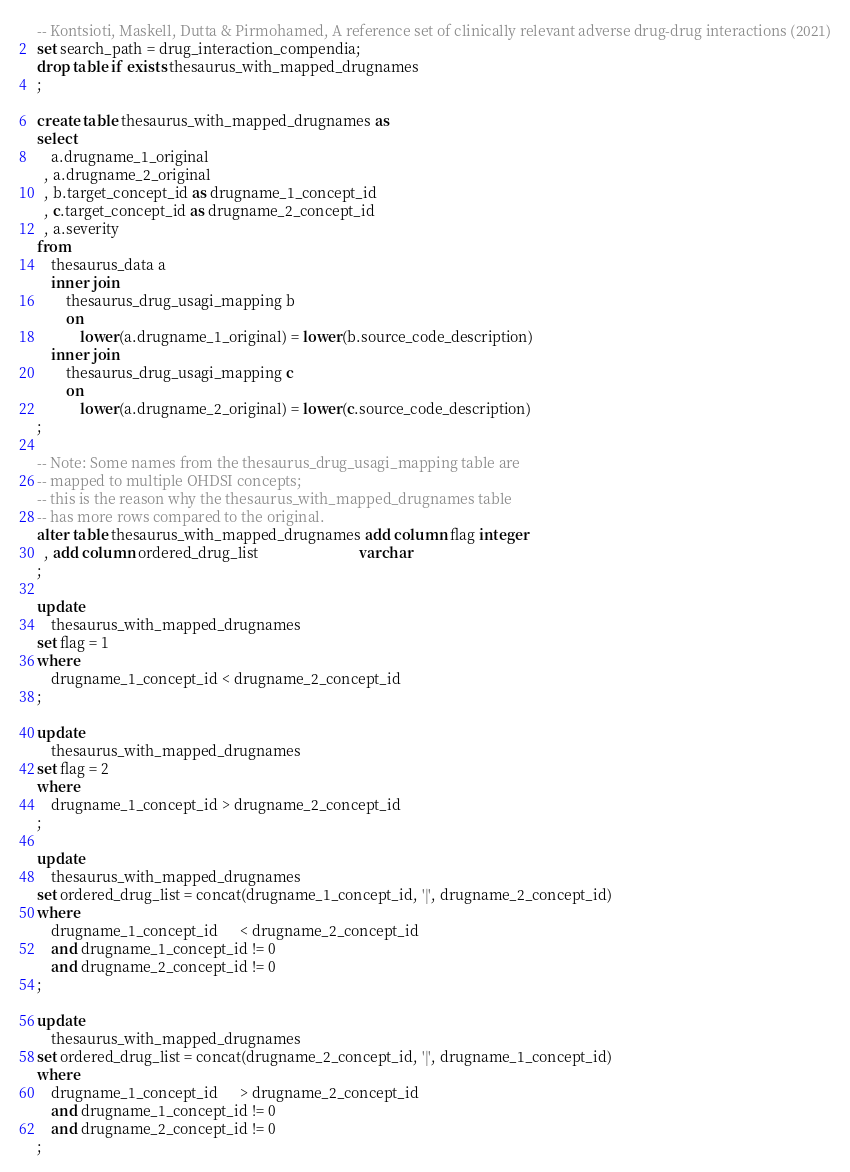Convert code to text. <code><loc_0><loc_0><loc_500><loc_500><_SQL_>-- Kontsioti, Maskell, Dutta & Pirmohamed, A reference set of clinically relevant adverse drug-drug interactions (2021)
set search_path = drug_interaction_compendia;
drop table if exists thesaurus_with_mapped_drugnames
;

create table thesaurus_with_mapped_drugnames as
select
    a.drugname_1_original
  , a.drugname_2_original
  , b.target_concept_id as drugname_1_concept_id
  , c.target_concept_id as drugname_2_concept_id
  , a.severity
from
    thesaurus_data a
    inner join
        thesaurus_drug_usagi_mapping b
        on
            lower(a.drugname_1_original) = lower(b.source_code_description)
    inner join
        thesaurus_drug_usagi_mapping c
        on
            lower(a.drugname_2_original) = lower(c.source_code_description)
;

-- Note: Some names from the thesaurus_drug_usagi_mapping table are 
-- mapped to multiple OHDSI concepts;
-- this is the reason why the thesaurus_with_mapped_drugnames table 
-- has more rows compared to the original.
alter table thesaurus_with_mapped_drugnames add column flag integer
  , add column ordered_drug_list                            varchar
;

update
    thesaurus_with_mapped_drugnames
set flag = 1
where
    drugname_1_concept_id < drugname_2_concept_id
;

update
    thesaurus_with_mapped_drugnames
set flag = 2
where
    drugname_1_concept_id > drugname_2_concept_id
;

update
    thesaurus_with_mapped_drugnames
set ordered_drug_list = concat(drugname_1_concept_id, '|', drugname_2_concept_id)
where
    drugname_1_concept_id      < drugname_2_concept_id
    and drugname_1_concept_id != 0
    and drugname_2_concept_id != 0
;

update
    thesaurus_with_mapped_drugnames
set ordered_drug_list = concat(drugname_2_concept_id, '|', drugname_1_concept_id)
where
    drugname_1_concept_id      > drugname_2_concept_id
    and drugname_1_concept_id != 0
    and drugname_2_concept_id != 0
;</code> 